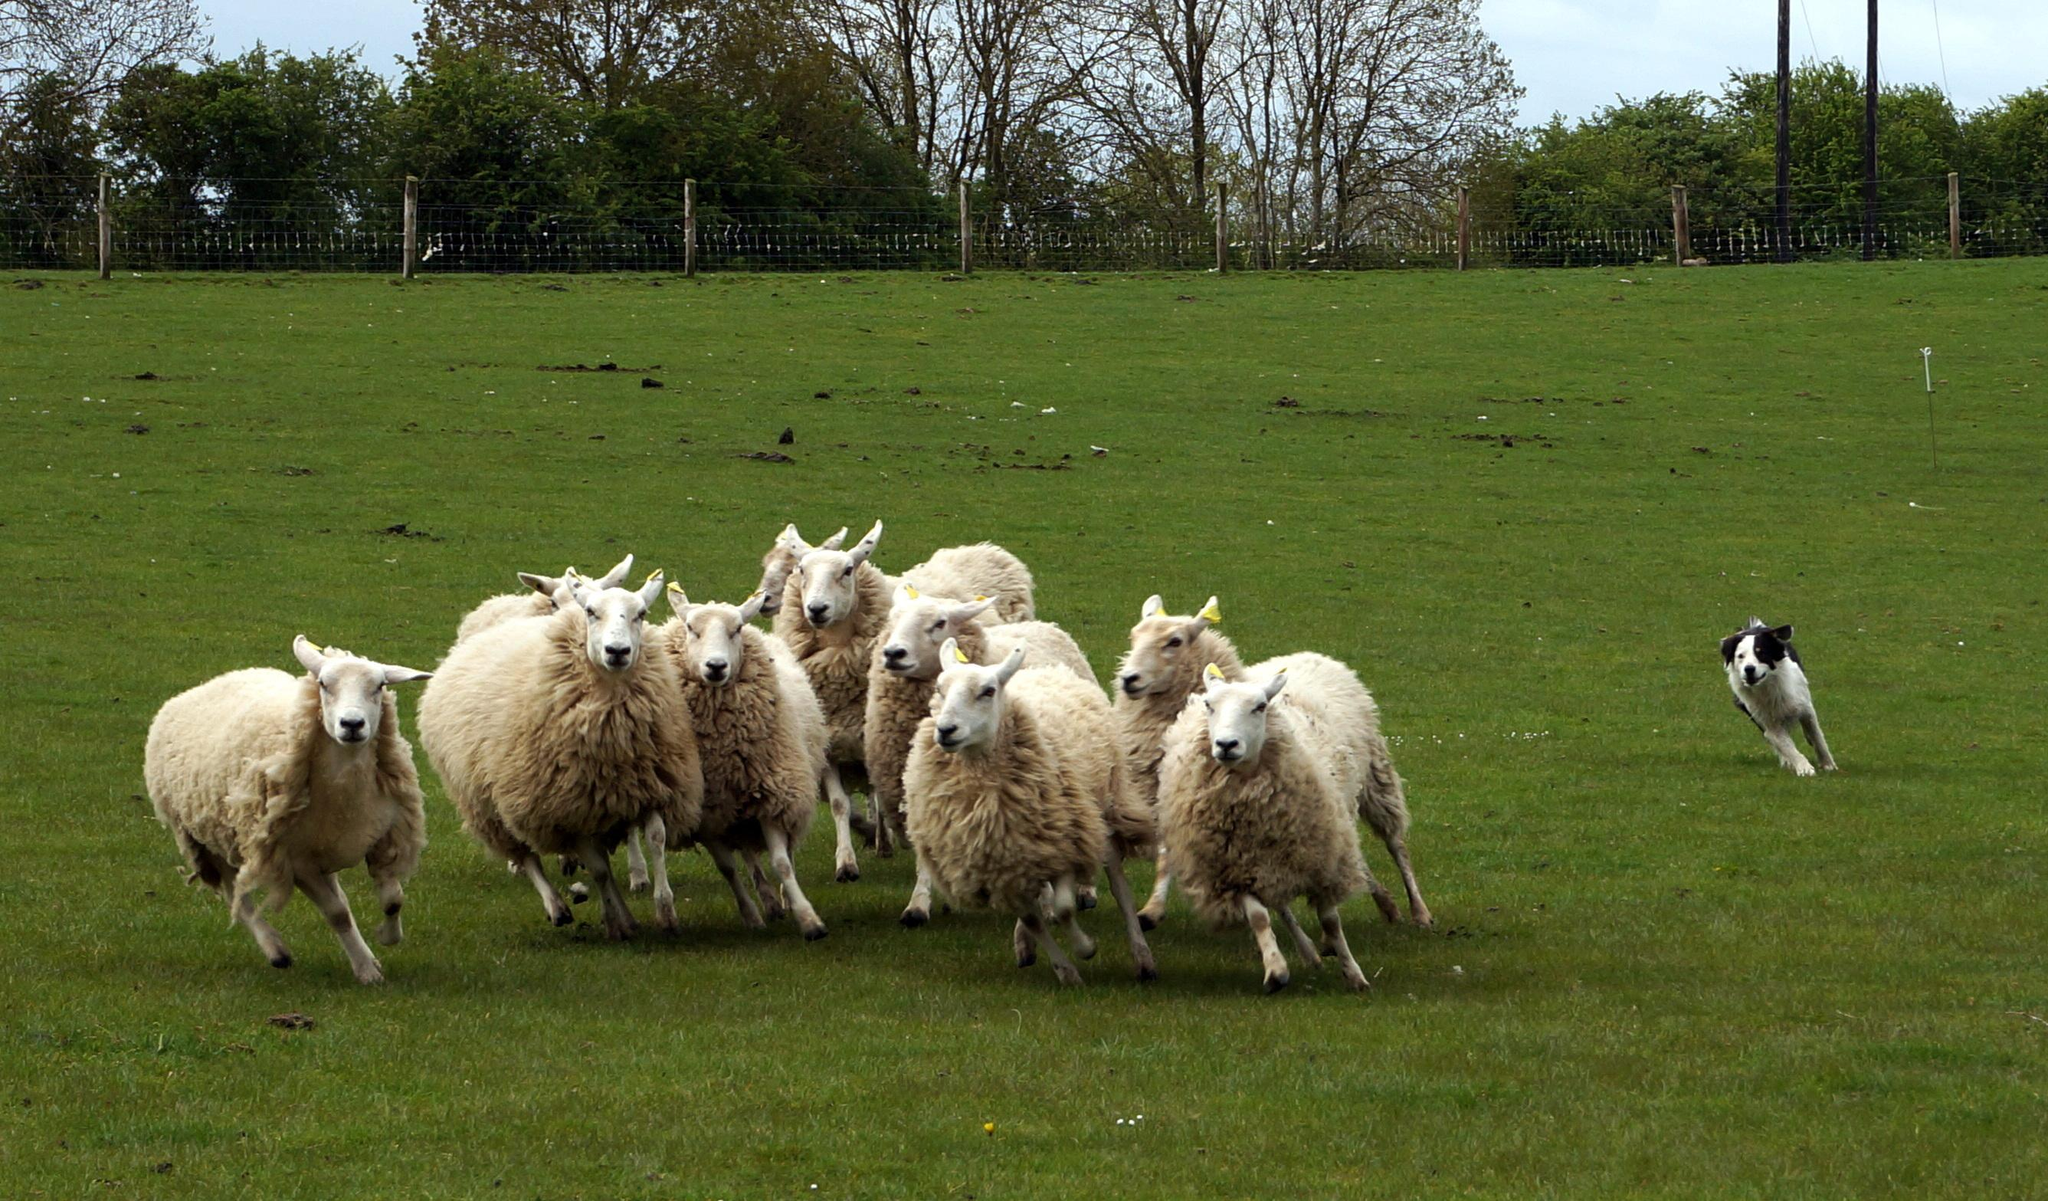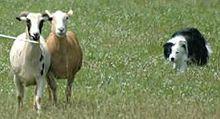The first image is the image on the left, the second image is the image on the right. Considering the images on both sides, is "An image shows a sheepdog with 3 sheep." valid? Answer yes or no. No. 